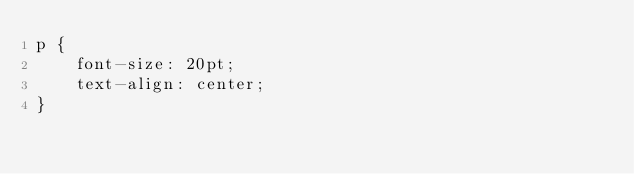Convert code to text. <code><loc_0><loc_0><loc_500><loc_500><_CSS_>p {
    font-size: 20pt;
    text-align: center;
}</code> 